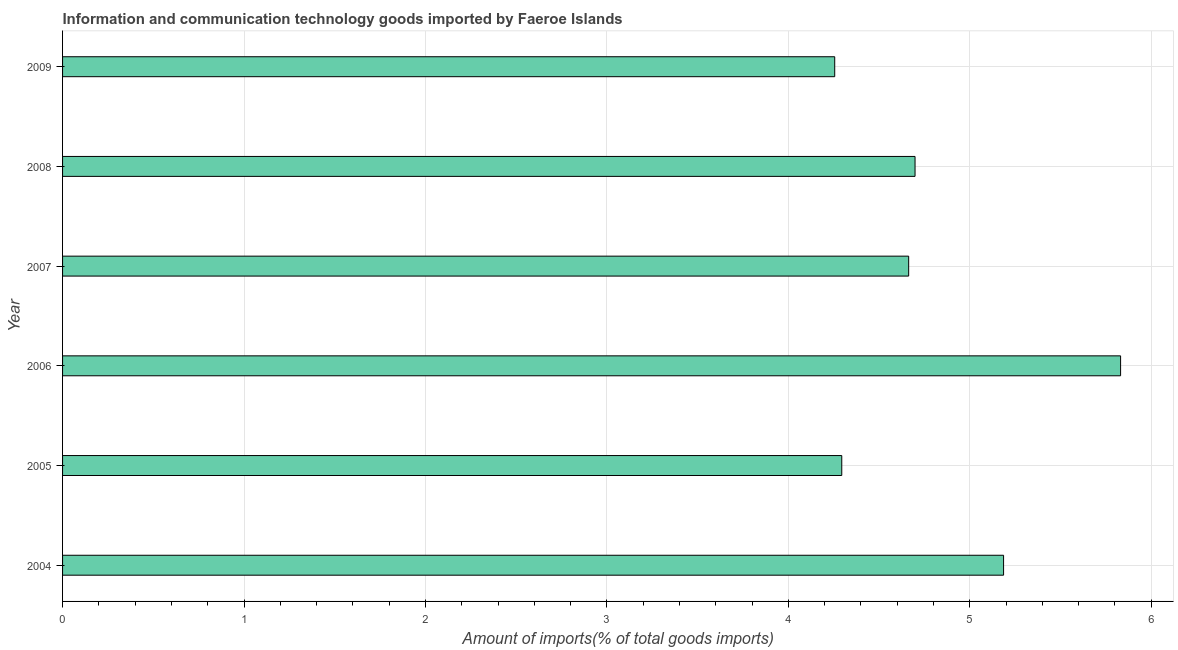Does the graph contain any zero values?
Your answer should be very brief. No. Does the graph contain grids?
Ensure brevity in your answer.  Yes. What is the title of the graph?
Ensure brevity in your answer.  Information and communication technology goods imported by Faeroe Islands. What is the label or title of the X-axis?
Your answer should be very brief. Amount of imports(% of total goods imports). What is the amount of ict goods imports in 2009?
Keep it short and to the point. 4.26. Across all years, what is the maximum amount of ict goods imports?
Your response must be concise. 5.83. Across all years, what is the minimum amount of ict goods imports?
Offer a terse response. 4.26. In which year was the amount of ict goods imports maximum?
Offer a terse response. 2006. What is the sum of the amount of ict goods imports?
Provide a succinct answer. 28.93. What is the difference between the amount of ict goods imports in 2008 and 2009?
Ensure brevity in your answer.  0.44. What is the average amount of ict goods imports per year?
Provide a succinct answer. 4.82. What is the median amount of ict goods imports?
Provide a succinct answer. 4.68. Do a majority of the years between 2008 and 2007 (inclusive) have amount of ict goods imports greater than 5.2 %?
Offer a very short reply. No. What is the ratio of the amount of ict goods imports in 2007 to that in 2009?
Give a very brief answer. 1.1. Is the difference between the amount of ict goods imports in 2004 and 2009 greater than the difference between any two years?
Your response must be concise. No. What is the difference between the highest and the second highest amount of ict goods imports?
Give a very brief answer. 0.65. What is the difference between the highest and the lowest amount of ict goods imports?
Make the answer very short. 1.58. In how many years, is the amount of ict goods imports greater than the average amount of ict goods imports taken over all years?
Provide a succinct answer. 2. How many bars are there?
Make the answer very short. 6. Are all the bars in the graph horizontal?
Your answer should be compact. Yes. What is the difference between two consecutive major ticks on the X-axis?
Your answer should be very brief. 1. What is the Amount of imports(% of total goods imports) in 2004?
Give a very brief answer. 5.19. What is the Amount of imports(% of total goods imports) of 2005?
Make the answer very short. 4.29. What is the Amount of imports(% of total goods imports) of 2006?
Your answer should be very brief. 5.83. What is the Amount of imports(% of total goods imports) of 2007?
Keep it short and to the point. 4.66. What is the Amount of imports(% of total goods imports) of 2008?
Your answer should be very brief. 4.7. What is the Amount of imports(% of total goods imports) in 2009?
Your answer should be very brief. 4.26. What is the difference between the Amount of imports(% of total goods imports) in 2004 and 2005?
Your answer should be compact. 0.89. What is the difference between the Amount of imports(% of total goods imports) in 2004 and 2006?
Your answer should be very brief. -0.64. What is the difference between the Amount of imports(% of total goods imports) in 2004 and 2007?
Your response must be concise. 0.52. What is the difference between the Amount of imports(% of total goods imports) in 2004 and 2008?
Your answer should be compact. 0.49. What is the difference between the Amount of imports(% of total goods imports) in 2004 and 2009?
Your answer should be very brief. 0.93. What is the difference between the Amount of imports(% of total goods imports) in 2005 and 2006?
Your answer should be compact. -1.54. What is the difference between the Amount of imports(% of total goods imports) in 2005 and 2007?
Ensure brevity in your answer.  -0.37. What is the difference between the Amount of imports(% of total goods imports) in 2005 and 2008?
Offer a very short reply. -0.4. What is the difference between the Amount of imports(% of total goods imports) in 2005 and 2009?
Provide a succinct answer. 0.04. What is the difference between the Amount of imports(% of total goods imports) in 2006 and 2007?
Provide a succinct answer. 1.17. What is the difference between the Amount of imports(% of total goods imports) in 2006 and 2008?
Your answer should be very brief. 1.13. What is the difference between the Amount of imports(% of total goods imports) in 2006 and 2009?
Ensure brevity in your answer.  1.58. What is the difference between the Amount of imports(% of total goods imports) in 2007 and 2008?
Ensure brevity in your answer.  -0.04. What is the difference between the Amount of imports(% of total goods imports) in 2007 and 2009?
Offer a terse response. 0.41. What is the difference between the Amount of imports(% of total goods imports) in 2008 and 2009?
Your response must be concise. 0.44. What is the ratio of the Amount of imports(% of total goods imports) in 2004 to that in 2005?
Provide a short and direct response. 1.21. What is the ratio of the Amount of imports(% of total goods imports) in 2004 to that in 2006?
Offer a terse response. 0.89. What is the ratio of the Amount of imports(% of total goods imports) in 2004 to that in 2007?
Ensure brevity in your answer.  1.11. What is the ratio of the Amount of imports(% of total goods imports) in 2004 to that in 2008?
Give a very brief answer. 1.1. What is the ratio of the Amount of imports(% of total goods imports) in 2004 to that in 2009?
Keep it short and to the point. 1.22. What is the ratio of the Amount of imports(% of total goods imports) in 2005 to that in 2006?
Your answer should be very brief. 0.74. What is the ratio of the Amount of imports(% of total goods imports) in 2005 to that in 2007?
Your answer should be compact. 0.92. What is the ratio of the Amount of imports(% of total goods imports) in 2005 to that in 2008?
Provide a short and direct response. 0.91. What is the ratio of the Amount of imports(% of total goods imports) in 2005 to that in 2009?
Provide a short and direct response. 1.01. What is the ratio of the Amount of imports(% of total goods imports) in 2006 to that in 2007?
Make the answer very short. 1.25. What is the ratio of the Amount of imports(% of total goods imports) in 2006 to that in 2008?
Keep it short and to the point. 1.24. What is the ratio of the Amount of imports(% of total goods imports) in 2006 to that in 2009?
Offer a very short reply. 1.37. What is the ratio of the Amount of imports(% of total goods imports) in 2007 to that in 2008?
Give a very brief answer. 0.99. What is the ratio of the Amount of imports(% of total goods imports) in 2007 to that in 2009?
Offer a very short reply. 1.1. What is the ratio of the Amount of imports(% of total goods imports) in 2008 to that in 2009?
Your answer should be very brief. 1.1. 